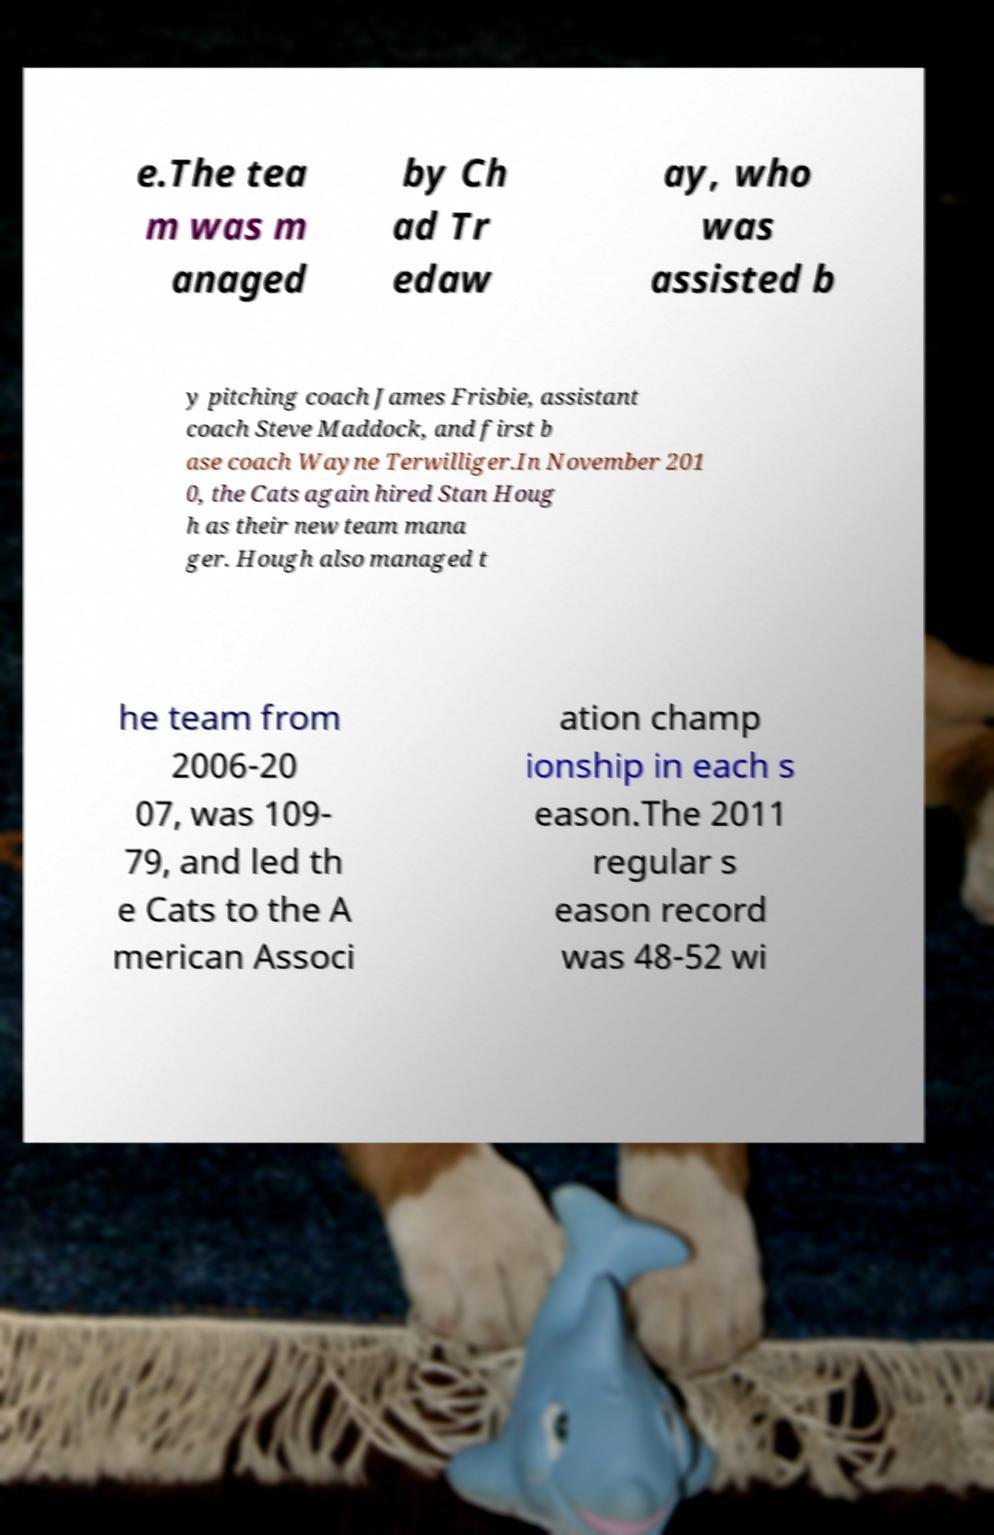Can you read and provide the text displayed in the image?This photo seems to have some interesting text. Can you extract and type it out for me? e.The tea m was m anaged by Ch ad Tr edaw ay, who was assisted b y pitching coach James Frisbie, assistant coach Steve Maddock, and first b ase coach Wayne Terwilliger.In November 201 0, the Cats again hired Stan Houg h as their new team mana ger. Hough also managed t he team from 2006-20 07, was 109- 79, and led th e Cats to the A merican Associ ation champ ionship in each s eason.The 2011 regular s eason record was 48-52 wi 